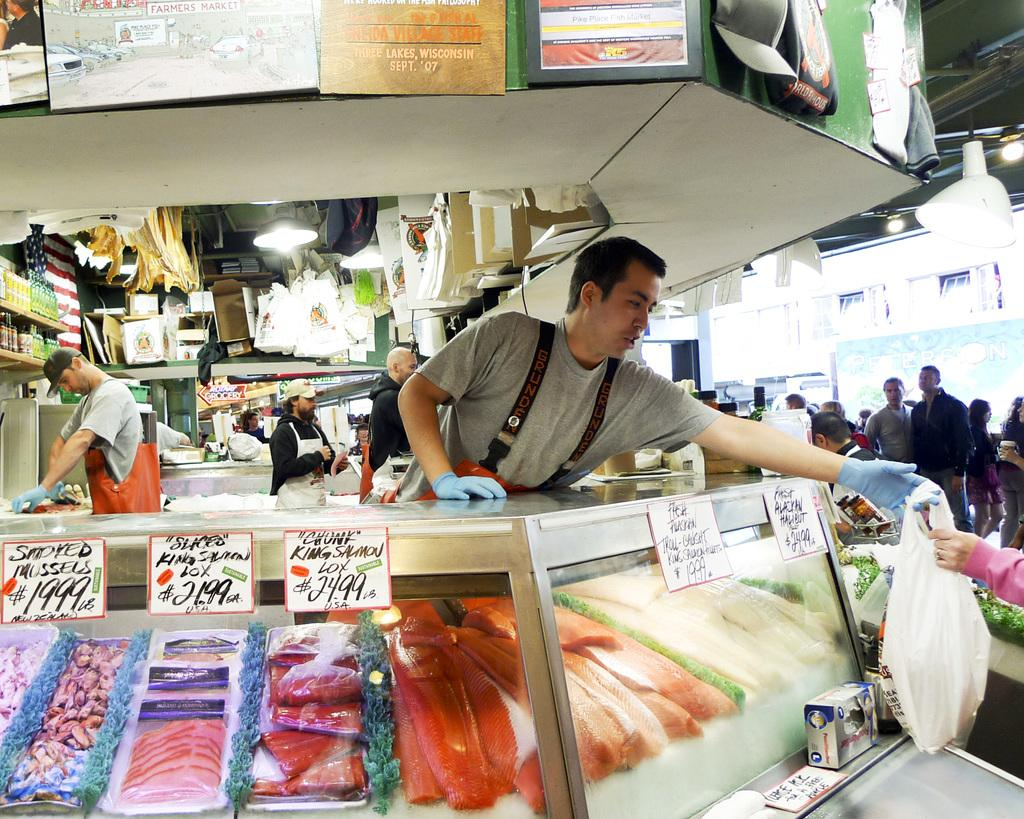<image>
Describe the image concisely. Men standing behind a clear glass fish counter with signed prices including "chunk" king salmon lox for $24.99. 